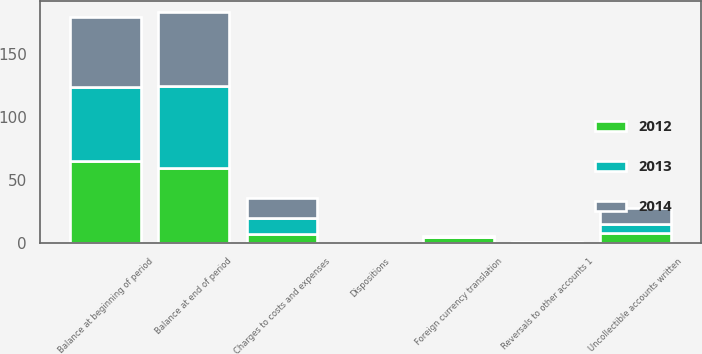Convert chart to OTSL. <chart><loc_0><loc_0><loc_500><loc_500><stacked_bar_chart><ecel><fcel>Balance at beginning of period<fcel>Charges to costs and expenses<fcel>Reversals to other accounts 1<fcel>Dispositions<fcel>Uncollectible accounts written<fcel>Foreign currency translation<fcel>Balance at end of period<nl><fcel>2012<fcel>64.9<fcel>7.4<fcel>0.1<fcel>0<fcel>8.1<fcel>4.8<fcel>59.5<nl><fcel>2013<fcel>59<fcel>12.6<fcel>0.7<fcel>0<fcel>7.2<fcel>0.2<fcel>64.9<nl><fcel>2014<fcel>55.4<fcel>16.3<fcel>0.2<fcel>0.4<fcel>12.6<fcel>0.5<fcel>59<nl></chart> 